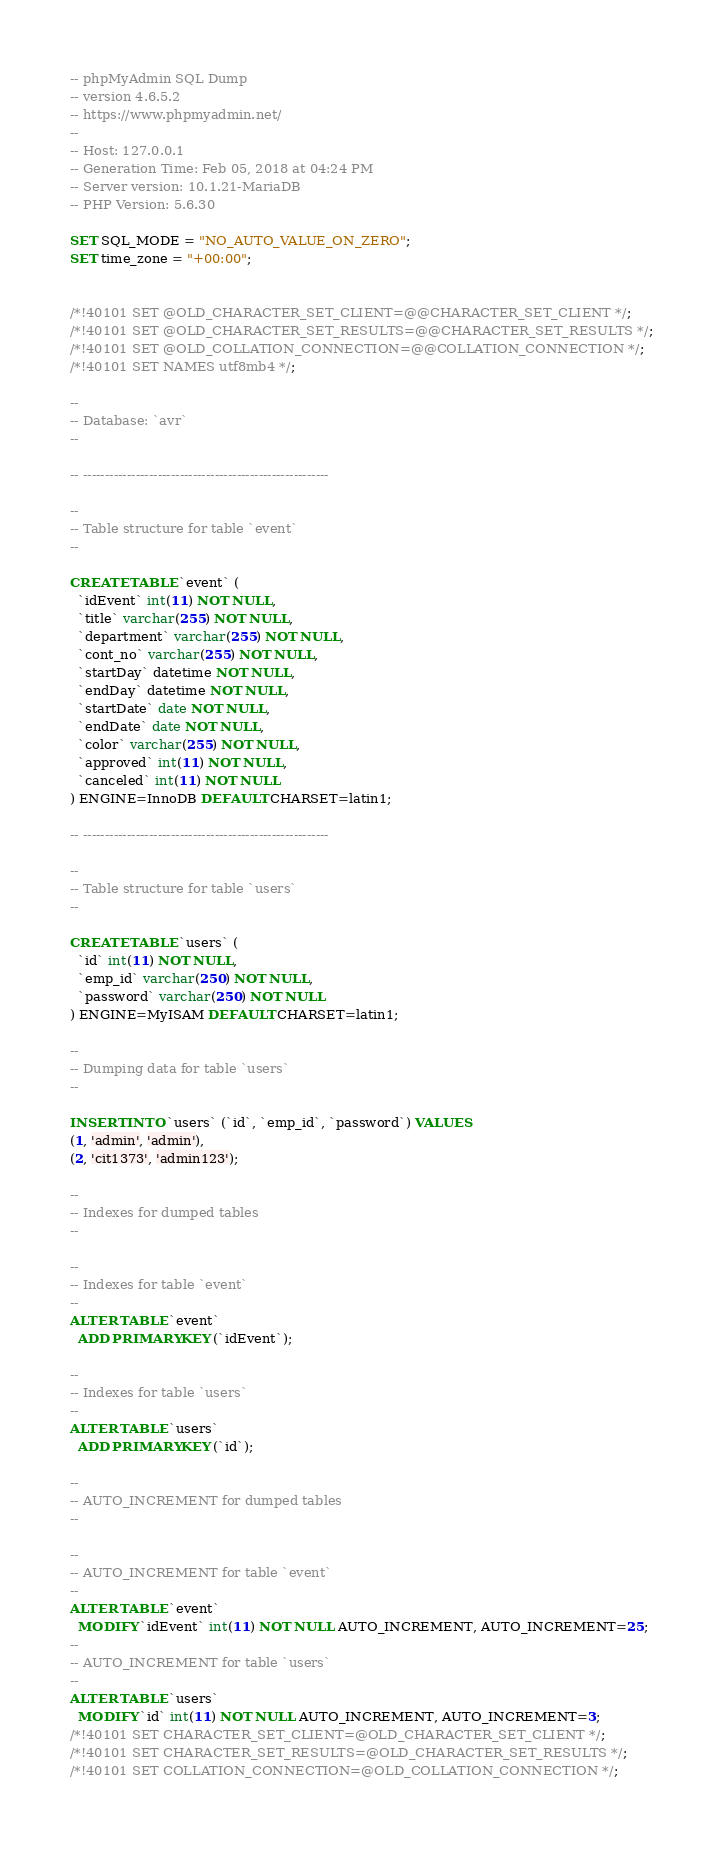<code> <loc_0><loc_0><loc_500><loc_500><_SQL_>-- phpMyAdmin SQL Dump
-- version 4.6.5.2
-- https://www.phpmyadmin.net/
--
-- Host: 127.0.0.1
-- Generation Time: Feb 05, 2018 at 04:24 PM
-- Server version: 10.1.21-MariaDB
-- PHP Version: 5.6.30

SET SQL_MODE = "NO_AUTO_VALUE_ON_ZERO";
SET time_zone = "+00:00";


/*!40101 SET @OLD_CHARACTER_SET_CLIENT=@@CHARACTER_SET_CLIENT */;
/*!40101 SET @OLD_CHARACTER_SET_RESULTS=@@CHARACTER_SET_RESULTS */;
/*!40101 SET @OLD_COLLATION_CONNECTION=@@COLLATION_CONNECTION */;
/*!40101 SET NAMES utf8mb4 */;

--
-- Database: `avr`
--

-- --------------------------------------------------------

--
-- Table structure for table `event`
--

CREATE TABLE `event` (
  `idEvent` int(11) NOT NULL,
  `title` varchar(255) NOT NULL,
  `department` varchar(255) NOT NULL,
  `cont_no` varchar(255) NOT NULL,
  `startDay` datetime NOT NULL,
  `endDay` datetime NOT NULL,
  `startDate` date NOT NULL,
  `endDate` date NOT NULL,
  `color` varchar(255) NOT NULL,
  `approved` int(11) NOT NULL,
  `canceled` int(11) NOT NULL
) ENGINE=InnoDB DEFAULT CHARSET=latin1;

-- --------------------------------------------------------

--
-- Table structure for table `users`
--

CREATE TABLE `users` (
  `id` int(11) NOT NULL,
  `emp_id` varchar(250) NOT NULL,
  `password` varchar(250) NOT NULL
) ENGINE=MyISAM DEFAULT CHARSET=latin1;

--
-- Dumping data for table `users`
--

INSERT INTO `users` (`id`, `emp_id`, `password`) VALUES
(1, 'admin', 'admin'),
(2, 'cit1373', 'admin123');

--
-- Indexes for dumped tables
--

--
-- Indexes for table `event`
--
ALTER TABLE `event`
  ADD PRIMARY KEY (`idEvent`);

--
-- Indexes for table `users`
--
ALTER TABLE `users`
  ADD PRIMARY KEY (`id`);

--
-- AUTO_INCREMENT for dumped tables
--

--
-- AUTO_INCREMENT for table `event`
--
ALTER TABLE `event`
  MODIFY `idEvent` int(11) NOT NULL AUTO_INCREMENT, AUTO_INCREMENT=25;
--
-- AUTO_INCREMENT for table `users`
--
ALTER TABLE `users`
  MODIFY `id` int(11) NOT NULL AUTO_INCREMENT, AUTO_INCREMENT=3;
/*!40101 SET CHARACTER_SET_CLIENT=@OLD_CHARACTER_SET_CLIENT */;
/*!40101 SET CHARACTER_SET_RESULTS=@OLD_CHARACTER_SET_RESULTS */;
/*!40101 SET COLLATION_CONNECTION=@OLD_COLLATION_CONNECTION */;
</code> 